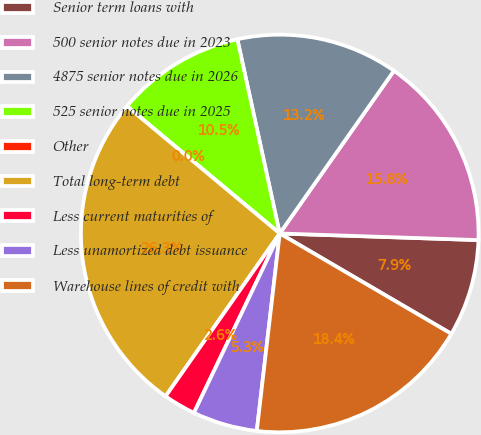<chart> <loc_0><loc_0><loc_500><loc_500><pie_chart><fcel>Senior term loans with<fcel>500 senior notes due in 2023<fcel>4875 senior notes due in 2026<fcel>525 senior notes due in 2025<fcel>Other<fcel>Total long-term debt<fcel>Less current maturities of<fcel>Less unamortized debt issuance<fcel>Warehouse lines of credit with<nl><fcel>7.89%<fcel>15.79%<fcel>13.16%<fcel>10.53%<fcel>0.0%<fcel>26.32%<fcel>2.63%<fcel>5.26%<fcel>18.42%<nl></chart> 